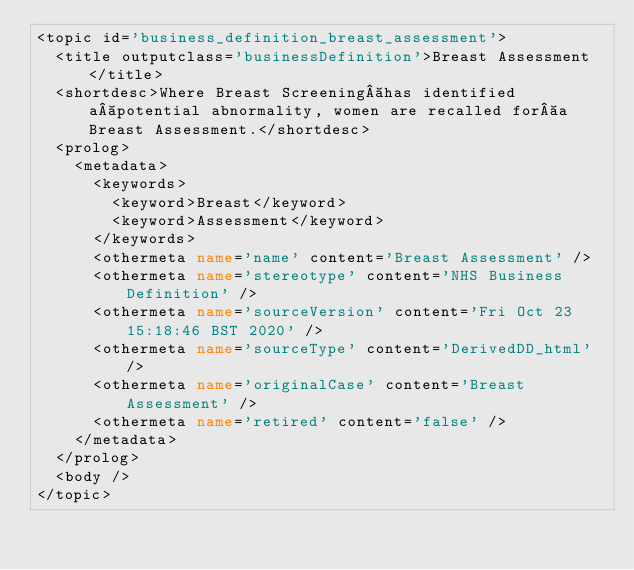<code> <loc_0><loc_0><loc_500><loc_500><_XML_><topic id='business_definition_breast_assessment'>
  <title outputclass='businessDefinition'>Breast Assessment</title>
  <shortdesc>Where Breast Screening has identified a potential abnormality, women are recalled for a Breast Assessment.</shortdesc>
  <prolog>
    <metadata>
      <keywords>
        <keyword>Breast</keyword>
        <keyword>Assessment</keyword>
      </keywords>
      <othermeta name='name' content='Breast Assessment' />
      <othermeta name='stereotype' content='NHS Business Definition' />
      <othermeta name='sourceVersion' content='Fri Oct 23 15:18:46 BST 2020' />
      <othermeta name='sourceType' content='DerivedDD_html' />
      <othermeta name='originalCase' content='Breast Assessment' />
      <othermeta name='retired' content='false' />
    </metadata>
  </prolog>
  <body />
</topic></code> 